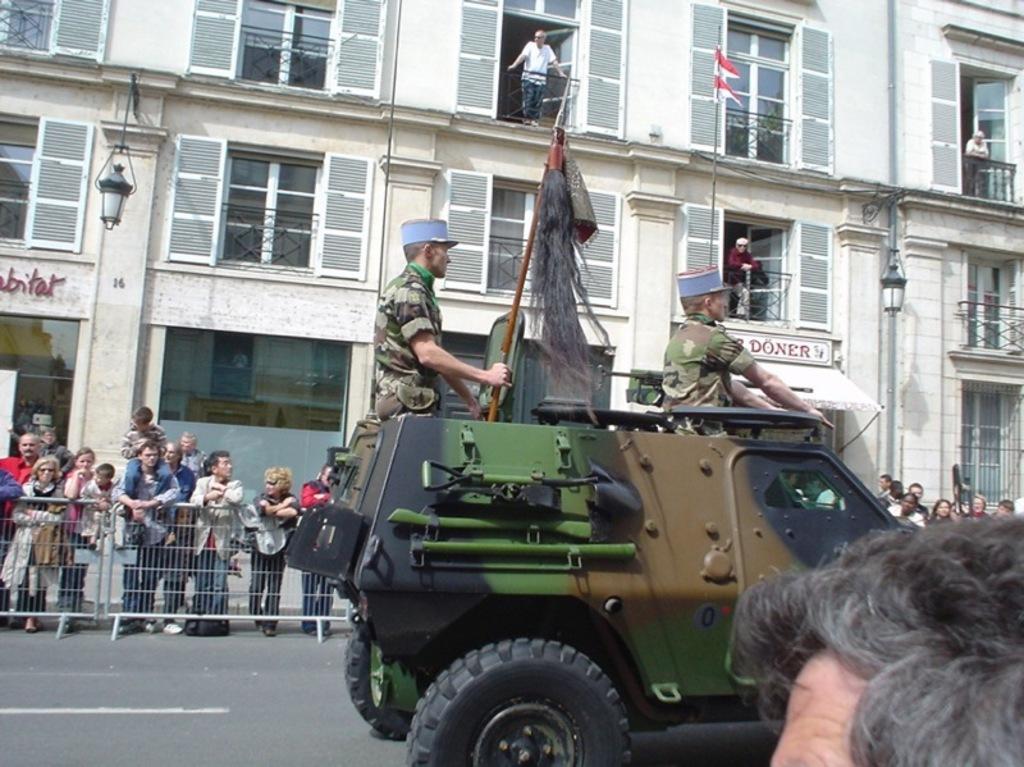Please provide a concise description of this image. In this image in the center there is a vehicle, and in the vehicle there are two people sitting and riding and in the bottom right hand corner there is one person's head is visible. And in the background there are buildings, railing and some people are standing and there is a railing and some text on the building and there is a pole and flag. At the bottom there is road. 